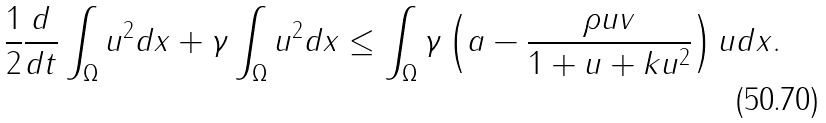<formula> <loc_0><loc_0><loc_500><loc_500>\frac { 1 } { 2 } \frac { d } { d t } \int _ { \Omega } u ^ { 2 } d x + \gamma \int _ { \Omega } u ^ { 2 } d x \leq \int _ { \Omega } \gamma \left ( a - \frac { \rho u v } { 1 + u + k u ^ { 2 } } \right ) u d x .</formula> 